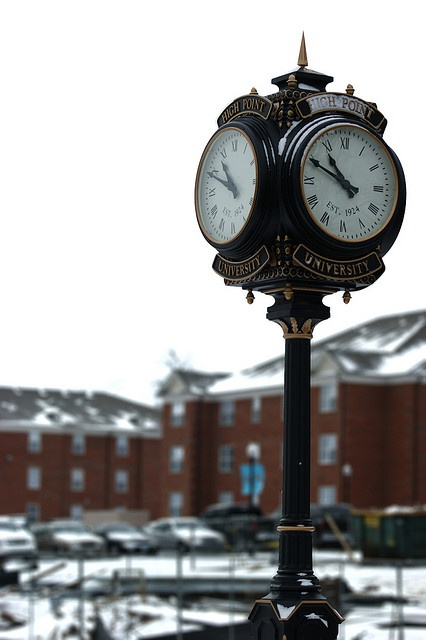Describe the objects in this image and their specific colors. I can see clock in white, gray, and black tones, clock in white, darkgray, gray, and black tones, car in white, black, purple, and darkgreen tones, car in white, gray, darkgray, black, and lightgray tones, and car in white, gray, darkgray, black, and lightgray tones in this image. 